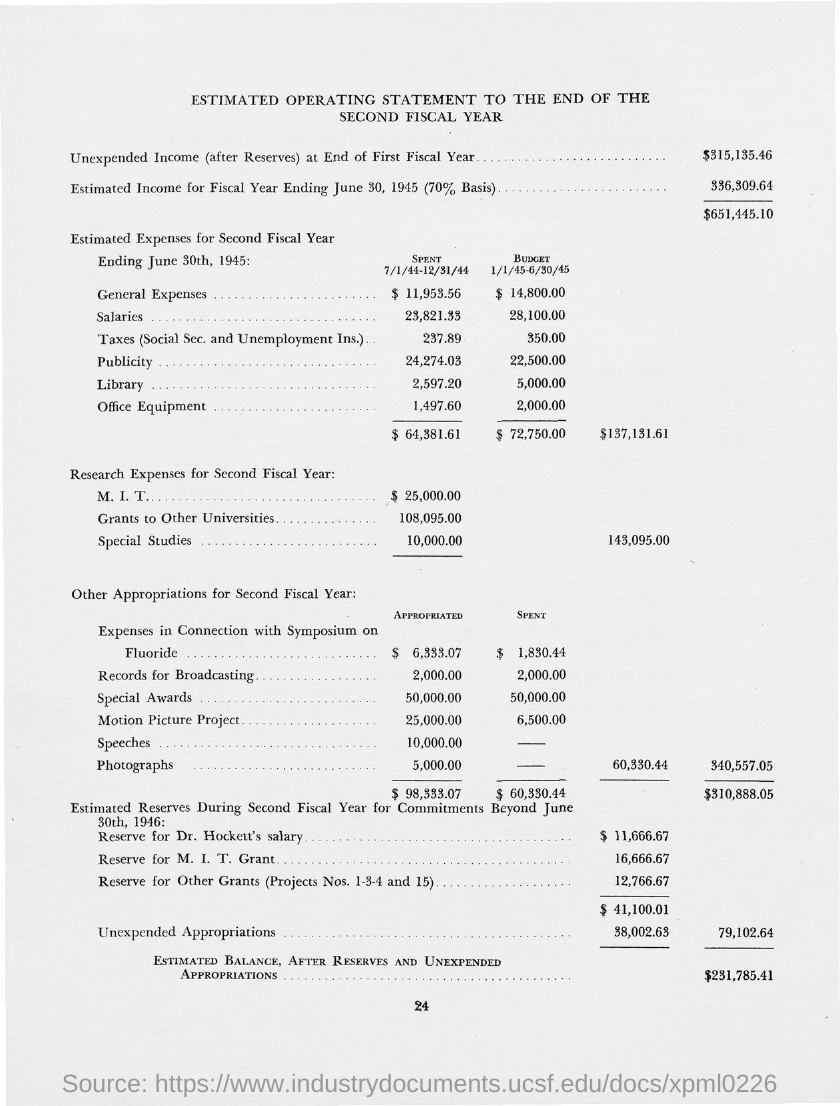Mention a couple of crucial points in this snapshot. The page number at the bottom of the page is 24. According to the estimated income for the fiscal year ending June 30, 1945, the income was $336,309.64, with a basis of 70%. UNEXPENDED INCOME (AFTER RESERVES) AT THE END OF THE FIRST FISCAL YEAR WAS $315,135.46. 